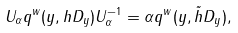Convert formula to latex. <formula><loc_0><loc_0><loc_500><loc_500>U _ { \alpha } q ^ { w } ( y , h D _ { y } ) U _ { \alpha } ^ { - 1 } = \alpha q ^ { w } ( y , \tilde { h } D _ { y } ) ,</formula> 